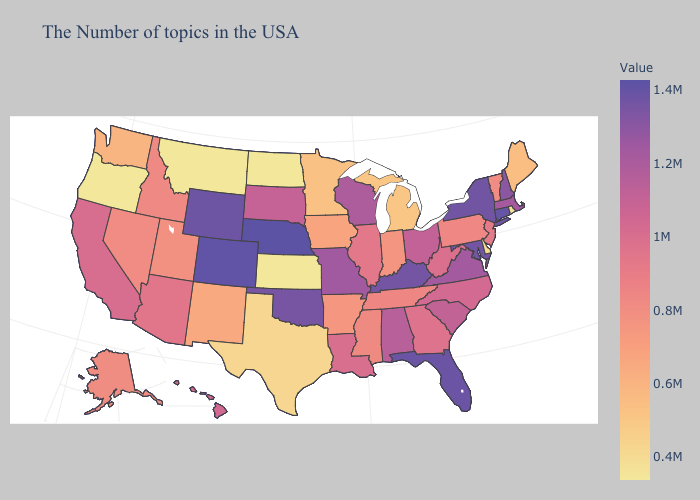Among the states that border Wyoming , does Nebraska have the highest value?
Short answer required. Yes. Which states have the highest value in the USA?
Quick response, please. Nebraska. Among the states that border New Hampshire , which have the highest value?
Concise answer only. Massachusetts. 